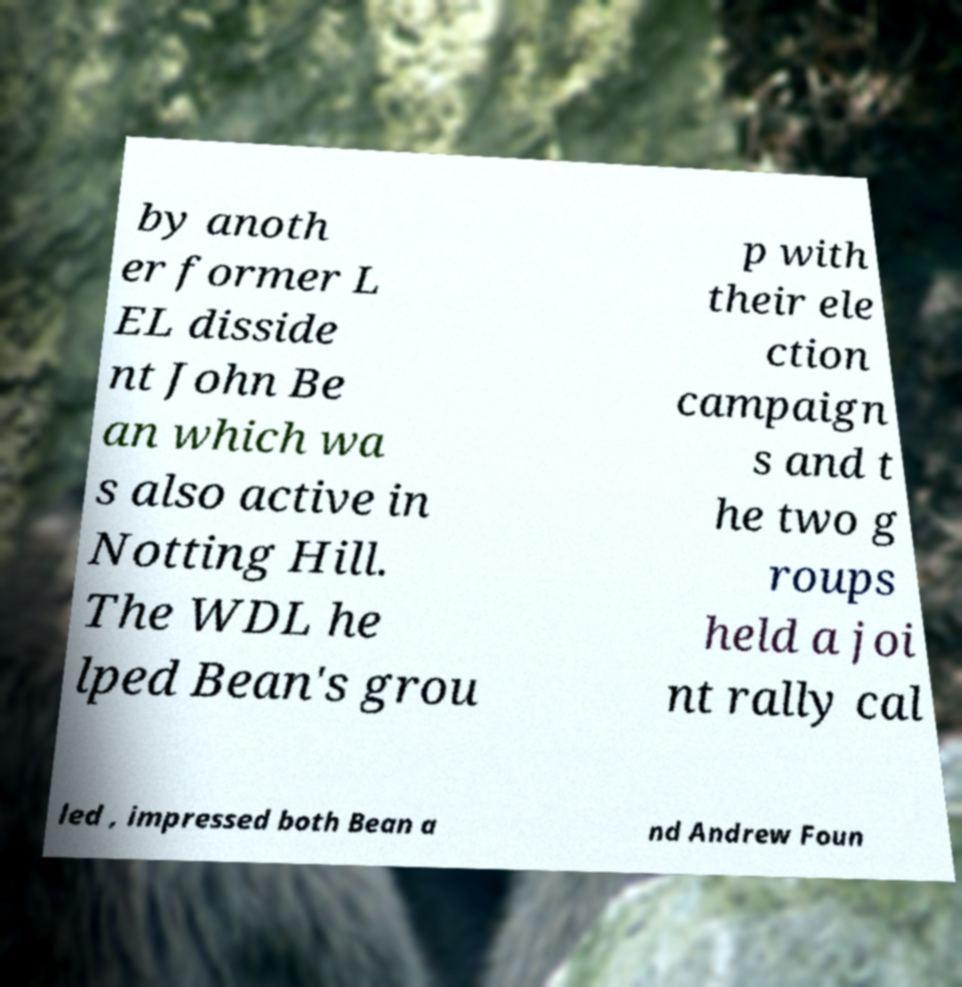Can you accurately transcribe the text from the provided image for me? by anoth er former L EL disside nt John Be an which wa s also active in Notting Hill. The WDL he lped Bean's grou p with their ele ction campaign s and t he two g roups held a joi nt rally cal led , impressed both Bean a nd Andrew Foun 